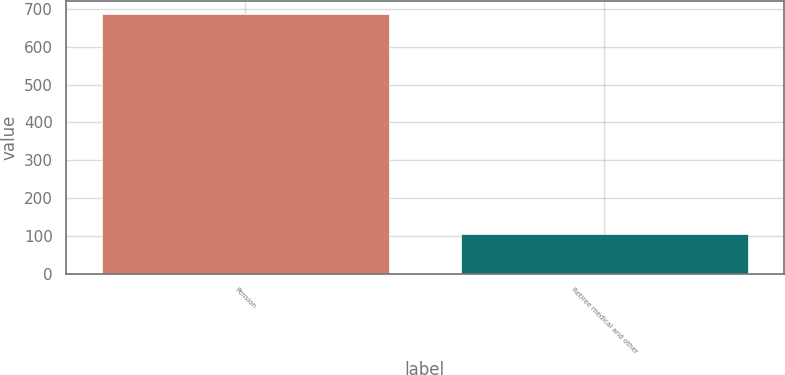Convert chart to OTSL. <chart><loc_0><loc_0><loc_500><loc_500><bar_chart><fcel>Pension<fcel>Retiree medical and other<nl><fcel>687<fcel>104<nl></chart> 